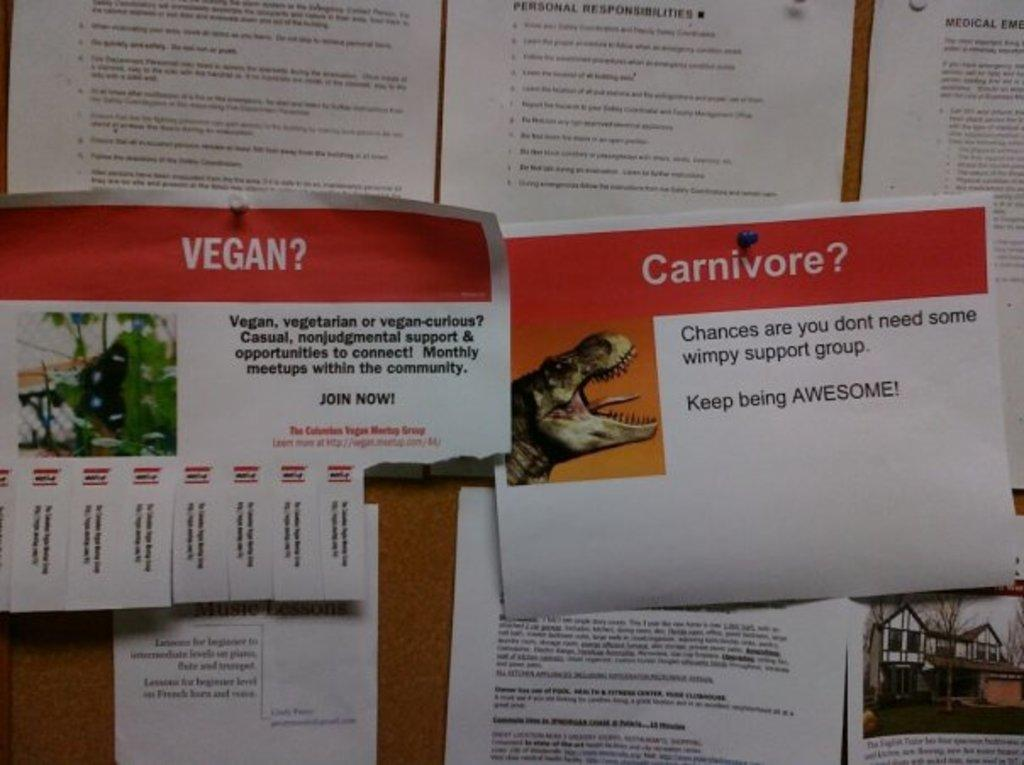What can be seen in the image? There are pipes in the image. How are the pipes connected or arranged? The pipes are attached to a wooden board. Is there a throne made of pipes in the image? No, there is no throne made of pipes in the image. The image only shows pipes attached to a wooden board. 